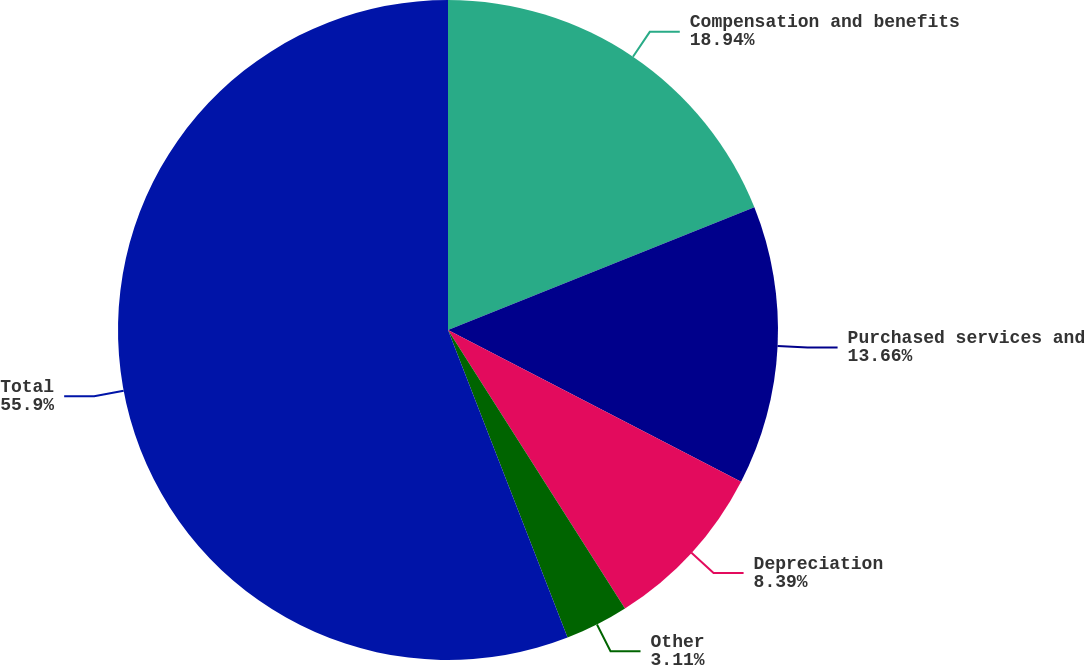Convert chart to OTSL. <chart><loc_0><loc_0><loc_500><loc_500><pie_chart><fcel>Compensation and benefits<fcel>Purchased services and<fcel>Depreciation<fcel>Other<fcel>Total<nl><fcel>18.94%<fcel>13.66%<fcel>8.39%<fcel>3.11%<fcel>55.9%<nl></chart> 